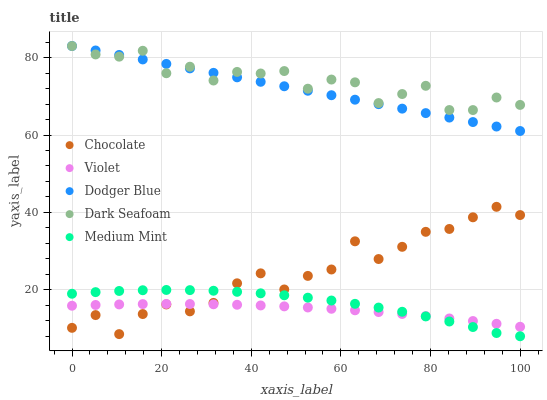Does Violet have the minimum area under the curve?
Answer yes or no. Yes. Does Dark Seafoam have the maximum area under the curve?
Answer yes or no. Yes. Does Dark Seafoam have the minimum area under the curve?
Answer yes or no. No. Does Violet have the maximum area under the curve?
Answer yes or no. No. Is Dodger Blue the smoothest?
Answer yes or no. Yes. Is Chocolate the roughest?
Answer yes or no. Yes. Is Dark Seafoam the smoothest?
Answer yes or no. No. Is Dark Seafoam the roughest?
Answer yes or no. No. Does Medium Mint have the lowest value?
Answer yes or no. Yes. Does Violet have the lowest value?
Answer yes or no. No. Does Dodger Blue have the highest value?
Answer yes or no. Yes. Does Violet have the highest value?
Answer yes or no. No. Is Medium Mint less than Dodger Blue?
Answer yes or no. Yes. Is Dark Seafoam greater than Violet?
Answer yes or no. Yes. Does Chocolate intersect Medium Mint?
Answer yes or no. Yes. Is Chocolate less than Medium Mint?
Answer yes or no. No. Is Chocolate greater than Medium Mint?
Answer yes or no. No. Does Medium Mint intersect Dodger Blue?
Answer yes or no. No. 